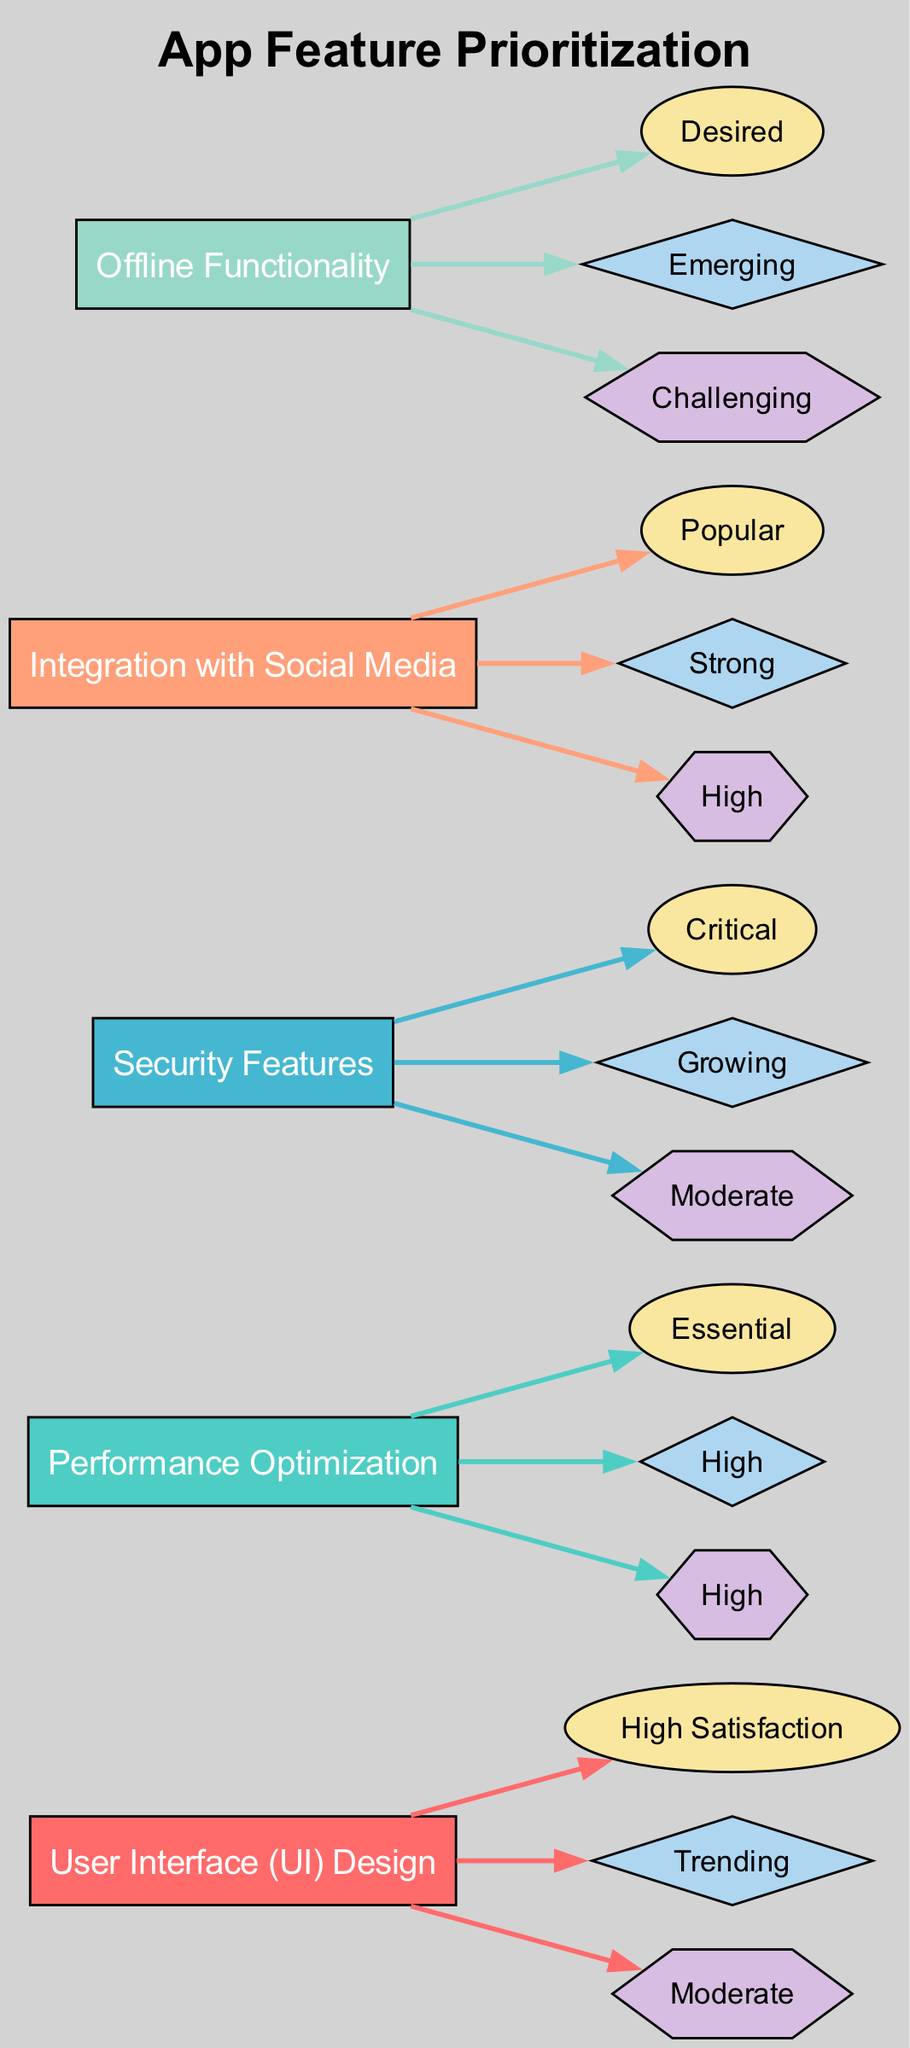What feature has the highest technical feasibility? By looking at the technical feasibility nodes in the diagram, I see that "Performance Optimization" and "Integration with Social Media" both show "High". However, "Performance Optimization" also rates as "Essential" in feedback, making it more prioritized despite equal feasibility.
Answer: Performance Optimization Which feature is marked as "Critical" in feedback? Checking the feedback nodes, "Security Features" is distinctly labeled as "Critical", signifying its importance based on user responses.
Answer: Security Features How many total features are represented in the diagram? The diagram includes five features: User Interface Design, Performance Optimization, Security Features, Integration with Social Media, and Offline Functionality. Thus, I conclude the total is five.
Answer: Five Which feature is associated with "Emerging" market demand? In the market demand nodes, "Offline Functionality" is uniquely marked as "Emerging", indicating its developing interest in the current landscape.
Answer: Offline Functionality What is the feedback for "Integration with Social Media"? Looking at the feedback node for "Integration with Social Media", it shows "Popular", indicating user acceptance of this feature.
Answer: Popular Which feature shows a "High" market demand? When I examine the market demand, I find both "Performance Optimization" and "Integration with Social Media" marked as "High", but the question only asks for one, so I will state the first.
Answer: Performance Optimization Which feature has a "Desired" feedback rating? Upon scanning the feedback categories, "Offline Functionality" is specifically labeled as "Desired," indicating it is a favorable request from users.
Answer: Offline Functionality What node is linked with the highest number of edges? Analyzing the edges, I find that each feature has three outgoing edges representing feedback, market demand, and technical feasibility, which is equal across all. Thus, it would be accurate to state that all features share the same number of edges.
Answer: All features 